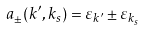Convert formula to latex. <formula><loc_0><loc_0><loc_500><loc_500>a _ { \pm } ( k ^ { \prime } , k _ { s } ) = \varepsilon _ { k ^ { \prime } } \pm \varepsilon _ { k _ { s } }</formula> 